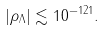<formula> <loc_0><loc_0><loc_500><loc_500>| \rho _ { \Lambda } | \lesssim 1 0 ^ { - 1 2 1 } .</formula> 